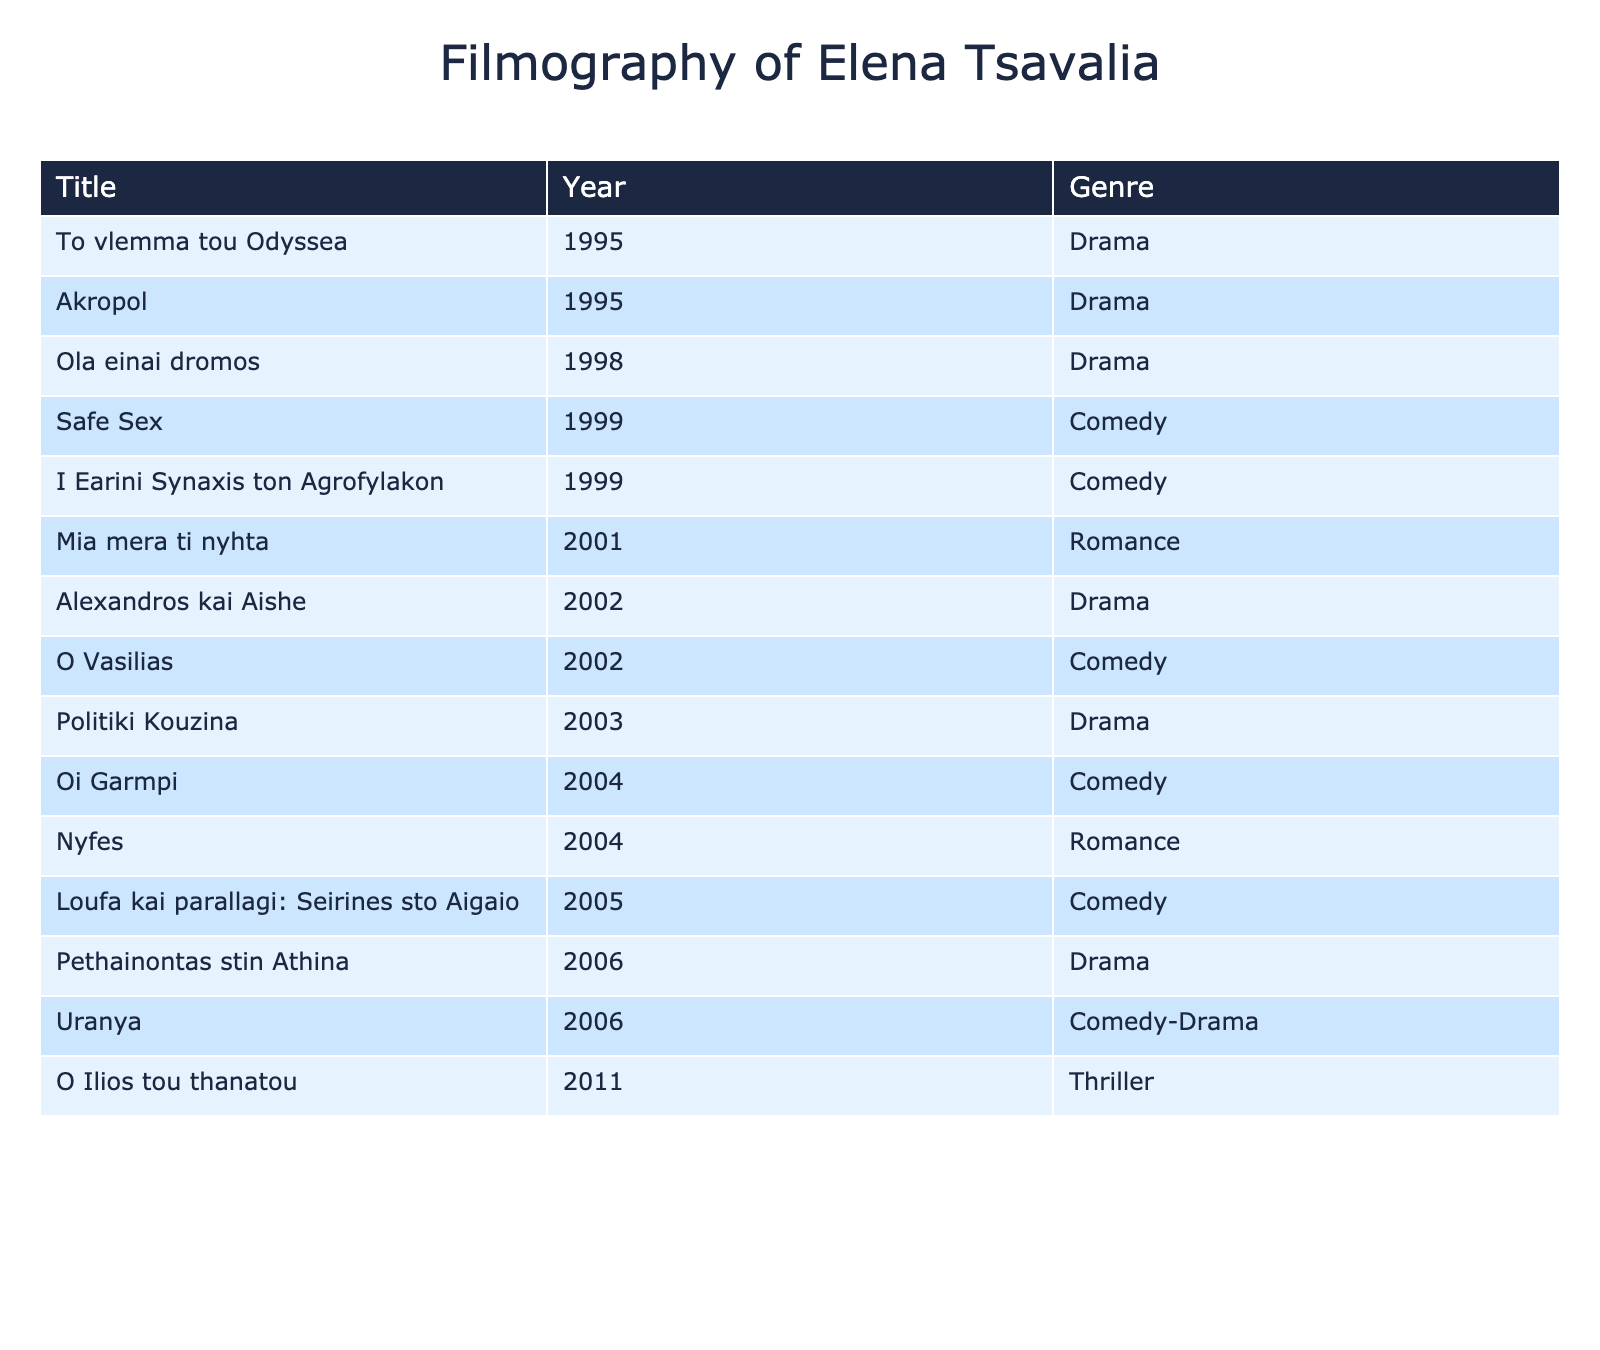What is the total number of films listed in Elena Tsavalia's filmography? By counting the number of rows in the table, we find that there are 15 titles listed under Elena Tsavalia's filmography.
Answer: 15 Which film was released in the year 2004? Looking at the "Year" column, the films listed for the year 2004 are "Oi Garmpi," "Nyfes," and "Loufa kai parallagi: Seirines sto Aigaio."
Answer: Oi Garmpi, Nyfes, Loufa kai parallagi: Seirines sto Aigaio What genre is the film "Safe Sex"? Referring to the table, the genre listed for "Safe Sex" is Comedy.
Answer: Comedy How many Drama films are there in Elena Tsavalia's filmography? By examining the "Genre" column, we can tally the number of entries categorized as Drama, which are "Politiki Kouzina," "Ola einai dromos," "Alexandros kai Aishe," "To vlemma tou Odyssea," "Akropol," "Pethainontas stin Athina." This totals to 6 Drama films.
Answer: 6 Which film represents the most recent work by Elena Tsavalia? By looking at the "Year" column, the most recent entry is "O Ilios tou thanatou" from 2011.
Answer: O Ilios tou thanatou What is the genre of the film "Mia mera ti nyhta"? The table indicates that "Mia mera ti nyhta" falls under the Romance genre.
Answer: Romance Did Elena Tsavalia release any films in 1999? Checking the table, we find two films, "Safe Sex" and "I Earini Synaxis ton Agrofylakon," released in 1999. Thus, the answer is yes.
Answer: Yes How many films were released in the 2000s (2000-2009)? Examining the years listed in the table, the films released in the 2000s are: "Mia mera ti nyhta" (2001), "Alexandros kai Aishe" (2002), "O Vasilias" (2002), "Oi Garmpi" (2004), "Nyfes" (2004), "Uranya" (2006), "Pethainontas stin Athina" (2006), and "O Ilios tou thanatou" (2011). Adding these, there are 8 films in the 2000s.
Answer: 8 What percentage of Elena Tsavalia's filmography is Comedy? There are 5 Comedy films out of a total of 15 films. To calculate the percentage, we divide 5 by 15 and multiply by 100, resulting in (5/15) * 100 = 33.33%.
Answer: 33.33% Which genre has the least representation in Elena Tsavalia's filmography? By counting the number of films in each genre, we find Comedy and Drama to be the most frequent, and Thriller only appears once with "O Ilios tou thanatou," indicating that Thriller has the least representation.
Answer: Thriller 